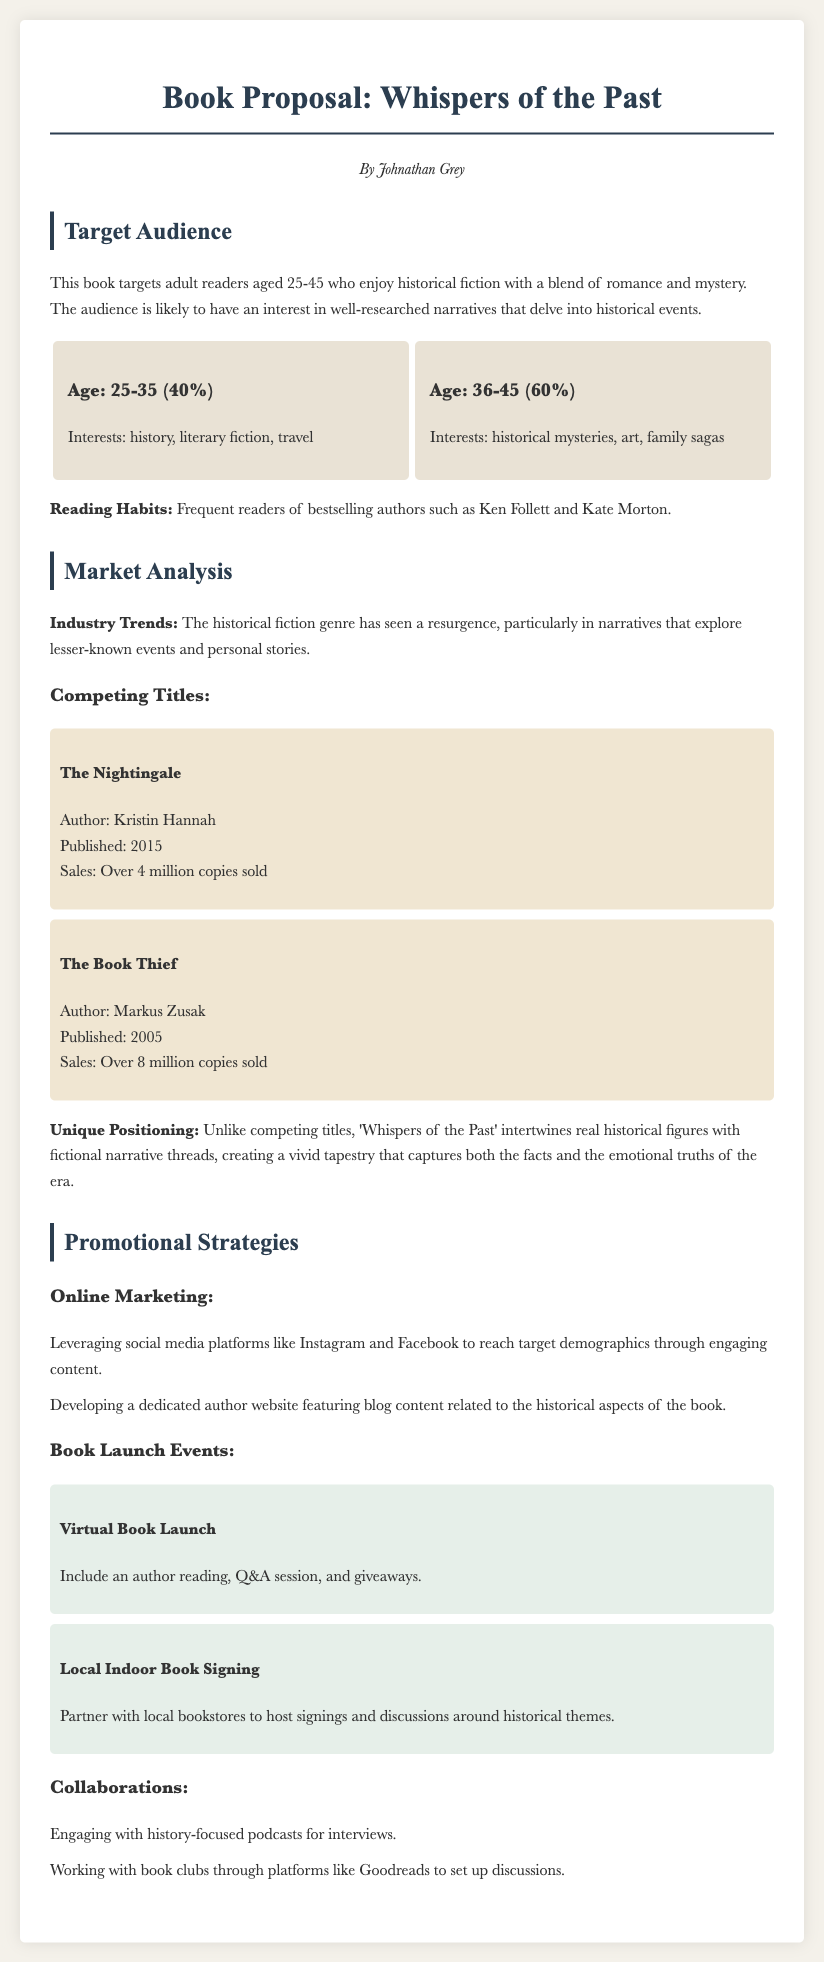What is the title of the book proposal? The title of the book proposal is prominently displayed in the document.
Answer: Whispers of the Past Who is the author of the book? The author is introduced in the document's header section.
Answer: Johnathan Grey What percentage of the target audience is aged 36-45? The demographic split is provided in the target audience section.
Answer: 60% Which competing title has sold over 8 million copies? The competing titles section lists the sales figures for each mentioned title.
Answer: The Book Thief What is one promotional strategy mentioned for online marketing? The promotional strategies section provides specific tactics for online marketing.
Answer: Leveraging social media platforms What type of event is included in the promotional strategies? Specific types of events are mentioned under the promotional strategies section.
Answer: Virtual Book Launch What interests are associated with the 25-35 age demographic? The document specifies interests linked to different demographics.
Answer: history, literary fiction, travel What is the unique positioning of 'Whispers of the Past'? The unique aspects of the book are outlined in the market analysis section.
Answer: intertwines real historical figures with fictional narrative threads 